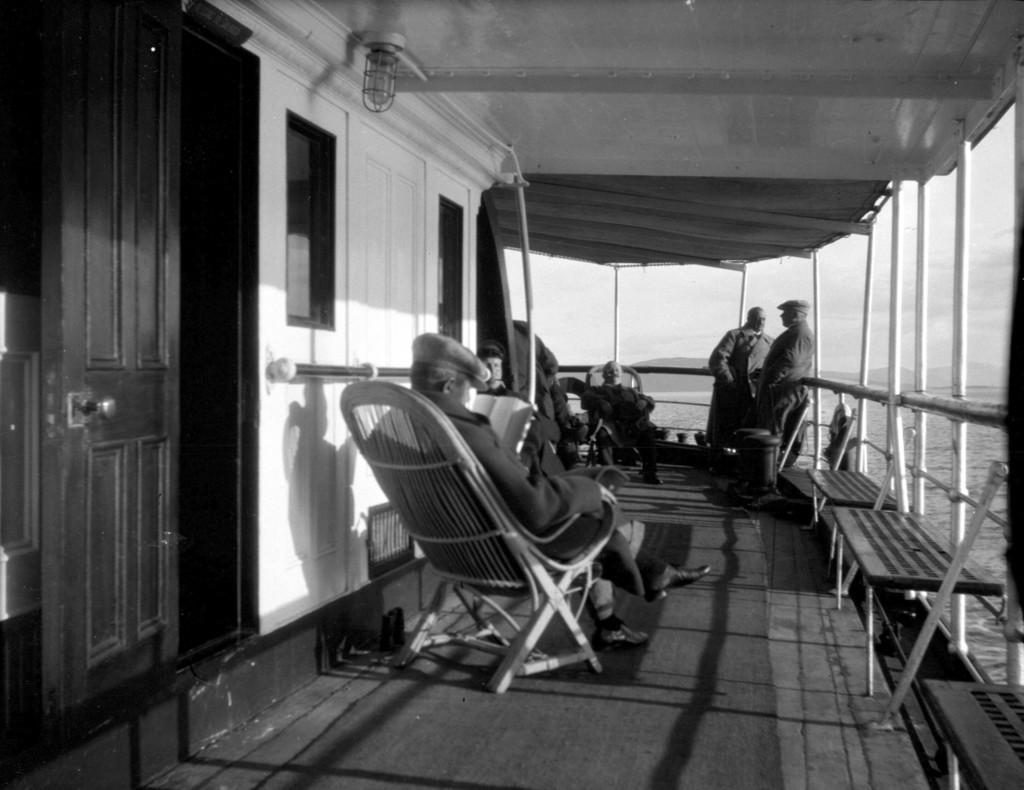Where are the persons in the image located? There are persons sitting in the left corner of the image, and two persons standing in the right corner of the image. What are the standing persons doing in the image? The standing persons are beside a fence in the right corner of the image. What can be seen in the background of the image? Water is visible in the background of the image. What type of skate is being used by the persons in the image? There is no skate present in the image; the persons are sitting and standing near a fence. Can you tell me which person is the chess achiever in the image? There is no mention of chess or an achiever in the image; it only shows persons sitting and standing near a fence with water visible in the background. 